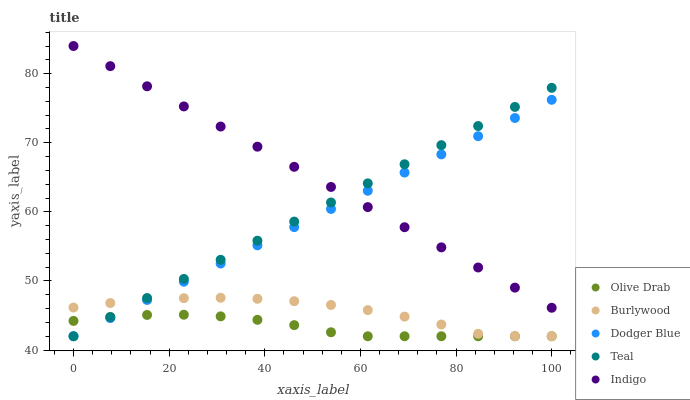Does Olive Drab have the minimum area under the curve?
Answer yes or no. Yes. Does Indigo have the maximum area under the curve?
Answer yes or no. Yes. Does Dodger Blue have the minimum area under the curve?
Answer yes or no. No. Does Dodger Blue have the maximum area under the curve?
Answer yes or no. No. Is Teal the smoothest?
Answer yes or no. Yes. Is Burlywood the roughest?
Answer yes or no. Yes. Is Indigo the smoothest?
Answer yes or no. No. Is Indigo the roughest?
Answer yes or no. No. Does Burlywood have the lowest value?
Answer yes or no. Yes. Does Indigo have the lowest value?
Answer yes or no. No. Does Indigo have the highest value?
Answer yes or no. Yes. Does Dodger Blue have the highest value?
Answer yes or no. No. Is Burlywood less than Indigo?
Answer yes or no. Yes. Is Indigo greater than Olive Drab?
Answer yes or no. Yes. Does Olive Drab intersect Dodger Blue?
Answer yes or no. Yes. Is Olive Drab less than Dodger Blue?
Answer yes or no. No. Is Olive Drab greater than Dodger Blue?
Answer yes or no. No. Does Burlywood intersect Indigo?
Answer yes or no. No. 